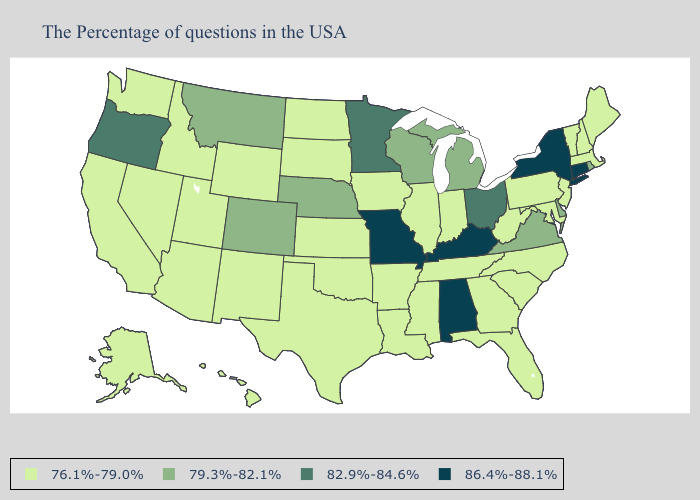Name the states that have a value in the range 82.9%-84.6%?
Concise answer only. Ohio, Minnesota, Oregon. Name the states that have a value in the range 86.4%-88.1%?
Concise answer only. Connecticut, New York, Kentucky, Alabama, Missouri. Name the states that have a value in the range 86.4%-88.1%?
Keep it brief. Connecticut, New York, Kentucky, Alabama, Missouri. What is the value of Indiana?
Be succinct. 76.1%-79.0%. Does Georgia have the highest value in the South?
Keep it brief. No. What is the lowest value in the USA?
Give a very brief answer. 76.1%-79.0%. Which states have the lowest value in the USA?
Write a very short answer. Maine, Massachusetts, New Hampshire, Vermont, New Jersey, Maryland, Pennsylvania, North Carolina, South Carolina, West Virginia, Florida, Georgia, Indiana, Tennessee, Illinois, Mississippi, Louisiana, Arkansas, Iowa, Kansas, Oklahoma, Texas, South Dakota, North Dakota, Wyoming, New Mexico, Utah, Arizona, Idaho, Nevada, California, Washington, Alaska, Hawaii. Does Oklahoma have a higher value than Nebraska?
Keep it brief. No. How many symbols are there in the legend?
Keep it brief. 4. Name the states that have a value in the range 86.4%-88.1%?
Be succinct. Connecticut, New York, Kentucky, Alabama, Missouri. Does Maine have the lowest value in the Northeast?
Keep it brief. Yes. Name the states that have a value in the range 82.9%-84.6%?
Concise answer only. Ohio, Minnesota, Oregon. Name the states that have a value in the range 86.4%-88.1%?
Write a very short answer. Connecticut, New York, Kentucky, Alabama, Missouri. Does the map have missing data?
Keep it brief. No. What is the highest value in the Northeast ?
Quick response, please. 86.4%-88.1%. 